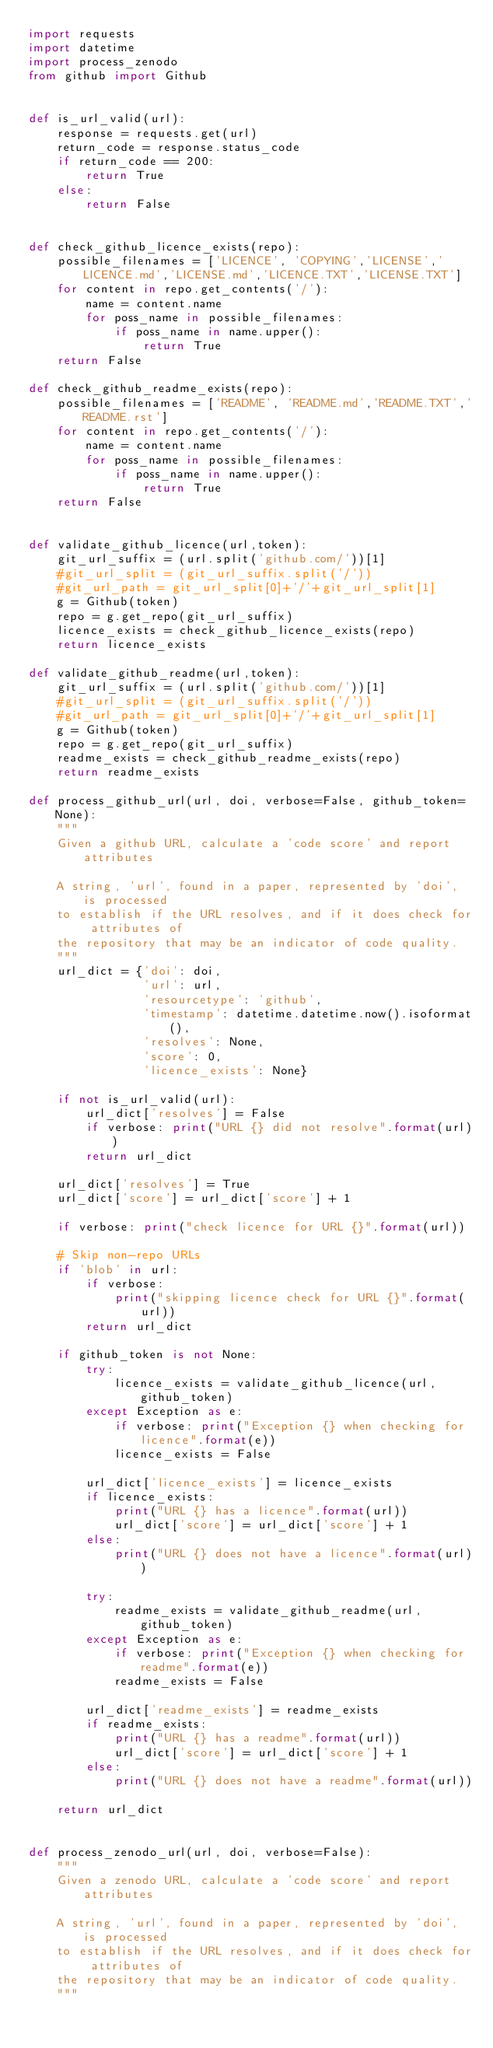<code> <loc_0><loc_0><loc_500><loc_500><_Python_>import requests
import datetime
import process_zenodo
from github import Github


def is_url_valid(url):
    response = requests.get(url)
    return_code = response.status_code
    if return_code == 200:
        return True
    else:
        return False

    
def check_github_licence_exists(repo):
    possible_filenames = ['LICENCE', 'COPYING','LICENSE','LICENCE.md','LICENSE.md','LICENCE.TXT','LICENSE.TXT']
    for content in repo.get_contents('/'):
        name = content.name
        for poss_name in possible_filenames:
            if poss_name in name.upper():
                return True
    return False

def check_github_readme_exists(repo):
    possible_filenames = ['README', 'README.md','README.TXT','README.rst']
    for content in repo.get_contents('/'):
        name = content.name
        for poss_name in possible_filenames:
            if poss_name in name.upper():
                return True
    return False

    
def validate_github_licence(url,token):  
    git_url_suffix = (url.split('github.com/'))[1]
    #git_url_split = (git_url_suffix.split('/'))
    #git_url_path = git_url_split[0]+'/'+git_url_split[1]
    g = Github(token)                 
    repo = g.get_repo(git_url_suffix)
    licence_exists = check_github_licence_exists(repo)
    return licence_exists

def validate_github_readme(url,token):  
    git_url_suffix = (url.split('github.com/'))[1]
    #git_url_split = (git_url_suffix.split('/'))
    #git_url_path = git_url_split[0]+'/'+git_url_split[1]
    g = Github(token)                 
    repo = g.get_repo(git_url_suffix)
    readme_exists = check_github_readme_exists(repo)
    return readme_exists

def process_github_url(url, doi, verbose=False, github_token=None):
    """
    Given a github URL, calculate a 'code score' and report attributes
    
    A string, 'url', found in a paper, represented by 'doi', is processed
    to establish if the URL resolves, and if it does check for attributes of
    the repository that may be an indicator of code quality.
    """
    url_dict = {'doi': doi,
                'url': url,
                'resourcetype': 'github',
                'timestamp': datetime.datetime.now().isoformat(),
                'resolves': None,
                'score': 0,
                'licence_exists': None}

    if not is_url_valid(url):
        url_dict['resolves'] = False
        if verbose: print("URL {} did not resolve".format(url))
        return url_dict
    
    url_dict['resolves'] = True
    url_dict['score'] = url_dict['score'] + 1

    if verbose: print("check licence for URL {}".format(url))

    # Skip non-repo URLs
    if 'blob' in url:
        if verbose: 
            print("skipping licence check for URL {}".format(url))
        return url_dict
        
    if github_token is not None:
        try:
            licence_exists = validate_github_licence(url, github_token)
        except Exception as e:
            if verbose: print("Exception {} when checking for licence".format(e))
            licence_exists = False
           
        url_dict['licence_exists'] = licence_exists
        if licence_exists:
            print("URL {} has a licence".format(url))
            url_dict['score'] = url_dict['score'] + 1
        else:
            print("URL {} does not have a licence".format(url))
            
        try:
            readme_exists = validate_github_readme(url, github_token)
        except Exception as e:
            if verbose: print("Exception {} when checking for readme".format(e))
            readme_exists = False
           
        url_dict['readme_exists'] = readme_exists
        if readme_exists:
            print("URL {} has a readme".format(url))
            url_dict['score'] = url_dict['score'] + 1
        else:
            print("URL {} does not have a readme".format(url))
            
    return url_dict


def process_zenodo_url(url, doi, verbose=False):
    """
    Given a zenodo URL, calculate a 'code score' and report attributes
    
    A string, 'url', found in a paper, represented by 'doi', is processed
    to establish if the URL resolves, and if it does check for attributes of
    the repository that may be an indicator of code quality.
    """</code> 